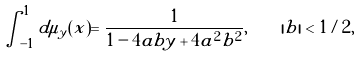Convert formula to latex. <formula><loc_0><loc_0><loc_500><loc_500>\int _ { - 1 } ^ { 1 } d \mu _ { y } ( x ) = \frac { 1 } { 1 - 4 a b y + 4 a ^ { 2 } b ^ { 2 } } , \quad | b | < 1 / 2 ,</formula> 